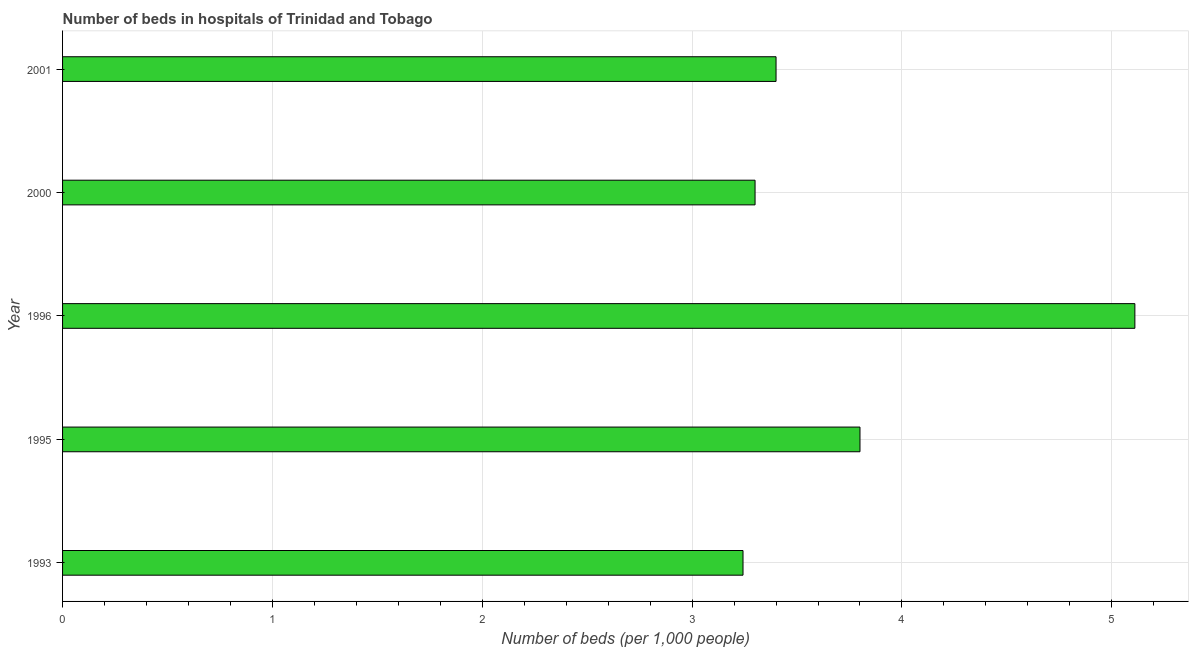What is the title of the graph?
Make the answer very short. Number of beds in hospitals of Trinidad and Tobago. What is the label or title of the X-axis?
Make the answer very short. Number of beds (per 1,0 people). What is the number of hospital beds in 1996?
Offer a very short reply. 5.11. Across all years, what is the maximum number of hospital beds?
Your answer should be very brief. 5.11. Across all years, what is the minimum number of hospital beds?
Provide a succinct answer. 3.24. In which year was the number of hospital beds minimum?
Offer a terse response. 1993. What is the sum of the number of hospital beds?
Keep it short and to the point. 18.85. What is the difference between the number of hospital beds in 1995 and 1996?
Your response must be concise. -1.31. What is the average number of hospital beds per year?
Make the answer very short. 3.77. What is the median number of hospital beds?
Your answer should be compact. 3.4. In how many years, is the number of hospital beds greater than 1.6 %?
Provide a succinct answer. 5. Is the number of hospital beds in 2000 less than that in 2001?
Your response must be concise. Yes. Is the difference between the number of hospital beds in 1995 and 1996 greater than the difference between any two years?
Offer a terse response. No. What is the difference between the highest and the second highest number of hospital beds?
Give a very brief answer. 1.31. What is the difference between the highest and the lowest number of hospital beds?
Make the answer very short. 1.87. What is the difference between two consecutive major ticks on the X-axis?
Provide a short and direct response. 1. What is the Number of beds (per 1,000 people) in 1993?
Your response must be concise. 3.24. What is the Number of beds (per 1,000 people) of 1996?
Provide a short and direct response. 5.11. What is the Number of beds (per 1,000 people) of 2000?
Provide a short and direct response. 3.3. What is the Number of beds (per 1,000 people) in 2001?
Offer a very short reply. 3.4. What is the difference between the Number of beds (per 1,000 people) in 1993 and 1995?
Offer a very short reply. -0.56. What is the difference between the Number of beds (per 1,000 people) in 1993 and 1996?
Provide a succinct answer. -1.87. What is the difference between the Number of beds (per 1,000 people) in 1993 and 2000?
Offer a terse response. -0.06. What is the difference between the Number of beds (per 1,000 people) in 1993 and 2001?
Ensure brevity in your answer.  -0.16. What is the difference between the Number of beds (per 1,000 people) in 1995 and 1996?
Make the answer very short. -1.31. What is the difference between the Number of beds (per 1,000 people) in 1995 and 2001?
Offer a terse response. 0.4. What is the difference between the Number of beds (per 1,000 people) in 1996 and 2000?
Offer a very short reply. 1.81. What is the difference between the Number of beds (per 1,000 people) in 1996 and 2001?
Provide a succinct answer. 1.71. What is the ratio of the Number of beds (per 1,000 people) in 1993 to that in 1995?
Keep it short and to the point. 0.85. What is the ratio of the Number of beds (per 1,000 people) in 1993 to that in 1996?
Your response must be concise. 0.64. What is the ratio of the Number of beds (per 1,000 people) in 1993 to that in 2001?
Your response must be concise. 0.95. What is the ratio of the Number of beds (per 1,000 people) in 1995 to that in 1996?
Ensure brevity in your answer.  0.74. What is the ratio of the Number of beds (per 1,000 people) in 1995 to that in 2000?
Offer a terse response. 1.15. What is the ratio of the Number of beds (per 1,000 people) in 1995 to that in 2001?
Provide a short and direct response. 1.12. What is the ratio of the Number of beds (per 1,000 people) in 1996 to that in 2000?
Your answer should be compact. 1.55. What is the ratio of the Number of beds (per 1,000 people) in 1996 to that in 2001?
Provide a succinct answer. 1.5. 